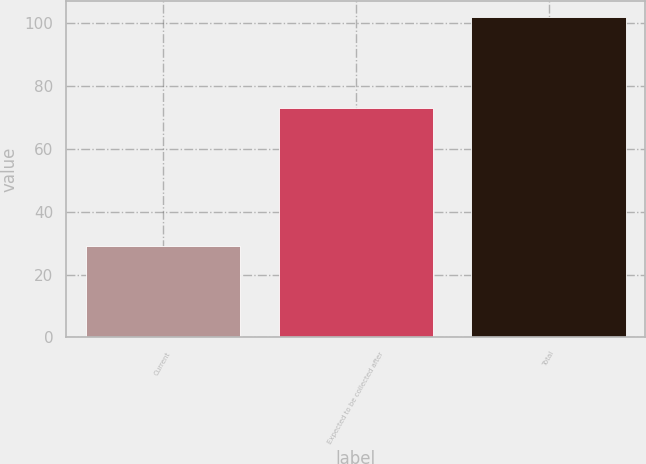<chart> <loc_0><loc_0><loc_500><loc_500><bar_chart><fcel>Current<fcel>Expected to be collected after<fcel>Total<nl><fcel>29<fcel>73<fcel>102<nl></chart> 